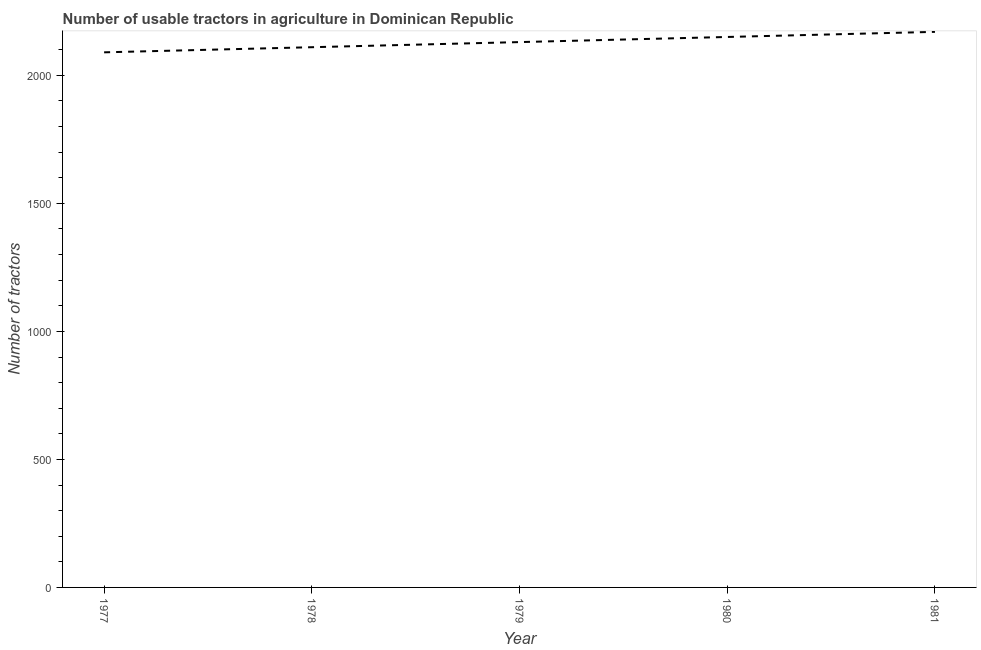What is the number of tractors in 1978?
Your response must be concise. 2110. Across all years, what is the maximum number of tractors?
Keep it short and to the point. 2170. Across all years, what is the minimum number of tractors?
Your answer should be compact. 2090. In which year was the number of tractors maximum?
Give a very brief answer. 1981. In which year was the number of tractors minimum?
Your answer should be very brief. 1977. What is the sum of the number of tractors?
Ensure brevity in your answer.  1.06e+04. What is the difference between the number of tractors in 1978 and 1979?
Ensure brevity in your answer.  -20. What is the average number of tractors per year?
Keep it short and to the point. 2130. What is the median number of tractors?
Offer a very short reply. 2130. What is the ratio of the number of tractors in 1979 to that in 1980?
Ensure brevity in your answer.  0.99. What is the difference between the highest and the lowest number of tractors?
Make the answer very short. 80. Does the number of tractors monotonically increase over the years?
Give a very brief answer. Yes. How many lines are there?
Your answer should be very brief. 1. How many years are there in the graph?
Provide a succinct answer. 5. Are the values on the major ticks of Y-axis written in scientific E-notation?
Your response must be concise. No. Does the graph contain grids?
Provide a succinct answer. No. What is the title of the graph?
Offer a very short reply. Number of usable tractors in agriculture in Dominican Republic. What is the label or title of the Y-axis?
Offer a very short reply. Number of tractors. What is the Number of tractors of 1977?
Offer a very short reply. 2090. What is the Number of tractors in 1978?
Ensure brevity in your answer.  2110. What is the Number of tractors in 1979?
Your answer should be very brief. 2130. What is the Number of tractors in 1980?
Ensure brevity in your answer.  2150. What is the Number of tractors of 1981?
Give a very brief answer. 2170. What is the difference between the Number of tractors in 1977 and 1980?
Provide a succinct answer. -60. What is the difference between the Number of tractors in 1977 and 1981?
Provide a short and direct response. -80. What is the difference between the Number of tractors in 1978 and 1980?
Your response must be concise. -40. What is the difference between the Number of tractors in 1978 and 1981?
Offer a terse response. -60. What is the difference between the Number of tractors in 1979 and 1981?
Keep it short and to the point. -40. What is the difference between the Number of tractors in 1980 and 1981?
Give a very brief answer. -20. What is the ratio of the Number of tractors in 1977 to that in 1978?
Make the answer very short. 0.99. What is the ratio of the Number of tractors in 1977 to that in 1979?
Offer a very short reply. 0.98. What is the ratio of the Number of tractors in 1978 to that in 1981?
Keep it short and to the point. 0.97. What is the ratio of the Number of tractors in 1979 to that in 1980?
Provide a succinct answer. 0.99. What is the ratio of the Number of tractors in 1979 to that in 1981?
Provide a succinct answer. 0.98. 